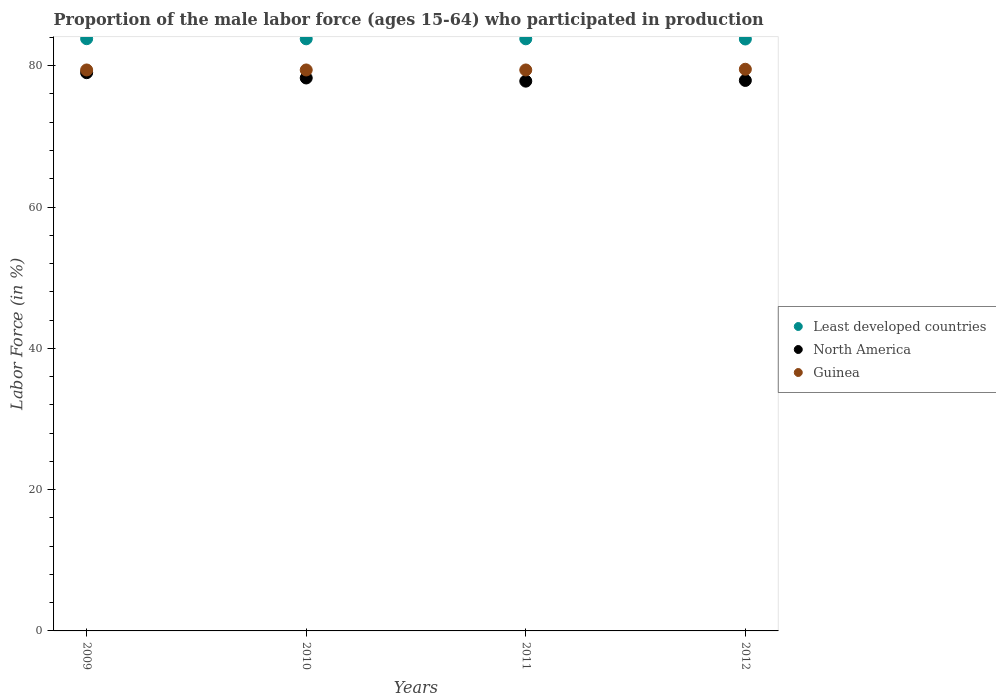What is the proportion of the male labor force who participated in production in North America in 2011?
Your answer should be compact. 77.82. Across all years, what is the maximum proportion of the male labor force who participated in production in Guinea?
Offer a terse response. 79.5. Across all years, what is the minimum proportion of the male labor force who participated in production in North America?
Offer a very short reply. 77.82. What is the total proportion of the male labor force who participated in production in Guinea in the graph?
Ensure brevity in your answer.  317.7. What is the difference between the proportion of the male labor force who participated in production in Least developed countries in 2010 and that in 2012?
Your response must be concise. 0.03. What is the difference between the proportion of the male labor force who participated in production in Least developed countries in 2011 and the proportion of the male labor force who participated in production in Guinea in 2009?
Offer a terse response. 4.41. What is the average proportion of the male labor force who participated in production in Least developed countries per year?
Your answer should be very brief. 83.81. In the year 2011, what is the difference between the proportion of the male labor force who participated in production in Guinea and proportion of the male labor force who participated in production in Least developed countries?
Your response must be concise. -4.41. What is the ratio of the proportion of the male labor force who participated in production in North America in 2009 to that in 2010?
Your response must be concise. 1.01. What is the difference between the highest and the second highest proportion of the male labor force who participated in production in Least developed countries?
Provide a short and direct response. 0.02. What is the difference between the highest and the lowest proportion of the male labor force who participated in production in North America?
Ensure brevity in your answer.  1.2. In how many years, is the proportion of the male labor force who participated in production in Least developed countries greater than the average proportion of the male labor force who participated in production in Least developed countries taken over all years?
Make the answer very short. 3. Does the proportion of the male labor force who participated in production in Least developed countries monotonically increase over the years?
Offer a terse response. No. Is the proportion of the male labor force who participated in production in Guinea strictly less than the proportion of the male labor force who participated in production in North America over the years?
Give a very brief answer. No. How many dotlines are there?
Offer a very short reply. 3. Does the graph contain any zero values?
Offer a very short reply. No. Where does the legend appear in the graph?
Offer a terse response. Center right. What is the title of the graph?
Your answer should be compact. Proportion of the male labor force (ages 15-64) who participated in production. What is the label or title of the Y-axis?
Offer a very short reply. Labor Force (in %). What is the Labor Force (in %) of Least developed countries in 2009?
Offer a terse response. 83.83. What is the Labor Force (in %) of North America in 2009?
Your answer should be very brief. 79.02. What is the Labor Force (in %) of Guinea in 2009?
Provide a short and direct response. 79.4. What is the Labor Force (in %) of Least developed countries in 2010?
Keep it short and to the point. 83.81. What is the Labor Force (in %) of North America in 2010?
Offer a terse response. 78.27. What is the Labor Force (in %) of Guinea in 2010?
Your answer should be very brief. 79.4. What is the Labor Force (in %) in Least developed countries in 2011?
Keep it short and to the point. 83.81. What is the Labor Force (in %) of North America in 2011?
Ensure brevity in your answer.  77.82. What is the Labor Force (in %) in Guinea in 2011?
Your response must be concise. 79.4. What is the Labor Force (in %) in Least developed countries in 2012?
Offer a very short reply. 83.78. What is the Labor Force (in %) of North America in 2012?
Keep it short and to the point. 77.92. What is the Labor Force (in %) in Guinea in 2012?
Offer a very short reply. 79.5. Across all years, what is the maximum Labor Force (in %) of Least developed countries?
Offer a very short reply. 83.83. Across all years, what is the maximum Labor Force (in %) of North America?
Give a very brief answer. 79.02. Across all years, what is the maximum Labor Force (in %) of Guinea?
Your answer should be very brief. 79.5. Across all years, what is the minimum Labor Force (in %) of Least developed countries?
Provide a short and direct response. 83.78. Across all years, what is the minimum Labor Force (in %) in North America?
Give a very brief answer. 77.82. Across all years, what is the minimum Labor Force (in %) of Guinea?
Keep it short and to the point. 79.4. What is the total Labor Force (in %) of Least developed countries in the graph?
Provide a succinct answer. 335.23. What is the total Labor Force (in %) in North America in the graph?
Offer a terse response. 313.02. What is the total Labor Force (in %) in Guinea in the graph?
Ensure brevity in your answer.  317.7. What is the difference between the Labor Force (in %) of Least developed countries in 2009 and that in 2010?
Provide a succinct answer. 0.02. What is the difference between the Labor Force (in %) in North America in 2009 and that in 2010?
Your answer should be compact. 0.75. What is the difference between the Labor Force (in %) in Guinea in 2009 and that in 2010?
Keep it short and to the point. 0. What is the difference between the Labor Force (in %) of Least developed countries in 2009 and that in 2011?
Make the answer very short. 0.02. What is the difference between the Labor Force (in %) of North America in 2009 and that in 2011?
Your response must be concise. 1.2. What is the difference between the Labor Force (in %) of Least developed countries in 2009 and that in 2012?
Ensure brevity in your answer.  0.04. What is the difference between the Labor Force (in %) in North America in 2009 and that in 2012?
Provide a short and direct response. 1.1. What is the difference between the Labor Force (in %) in Least developed countries in 2010 and that in 2011?
Your response must be concise. 0. What is the difference between the Labor Force (in %) in North America in 2010 and that in 2011?
Provide a short and direct response. 0.45. What is the difference between the Labor Force (in %) in Guinea in 2010 and that in 2011?
Your response must be concise. 0. What is the difference between the Labor Force (in %) in Least developed countries in 2010 and that in 2012?
Provide a short and direct response. 0.03. What is the difference between the Labor Force (in %) in North America in 2010 and that in 2012?
Your response must be concise. 0.35. What is the difference between the Labor Force (in %) of Guinea in 2010 and that in 2012?
Give a very brief answer. -0.1. What is the difference between the Labor Force (in %) of Least developed countries in 2011 and that in 2012?
Ensure brevity in your answer.  0.03. What is the difference between the Labor Force (in %) of North America in 2011 and that in 2012?
Give a very brief answer. -0.1. What is the difference between the Labor Force (in %) of Least developed countries in 2009 and the Labor Force (in %) of North America in 2010?
Provide a short and direct response. 5.56. What is the difference between the Labor Force (in %) in Least developed countries in 2009 and the Labor Force (in %) in Guinea in 2010?
Your response must be concise. 4.43. What is the difference between the Labor Force (in %) in North America in 2009 and the Labor Force (in %) in Guinea in 2010?
Your answer should be very brief. -0.38. What is the difference between the Labor Force (in %) of Least developed countries in 2009 and the Labor Force (in %) of North America in 2011?
Offer a very short reply. 6.01. What is the difference between the Labor Force (in %) in Least developed countries in 2009 and the Labor Force (in %) in Guinea in 2011?
Offer a terse response. 4.43. What is the difference between the Labor Force (in %) of North America in 2009 and the Labor Force (in %) of Guinea in 2011?
Offer a very short reply. -0.38. What is the difference between the Labor Force (in %) in Least developed countries in 2009 and the Labor Force (in %) in North America in 2012?
Offer a terse response. 5.91. What is the difference between the Labor Force (in %) in Least developed countries in 2009 and the Labor Force (in %) in Guinea in 2012?
Your response must be concise. 4.33. What is the difference between the Labor Force (in %) in North America in 2009 and the Labor Force (in %) in Guinea in 2012?
Give a very brief answer. -0.48. What is the difference between the Labor Force (in %) of Least developed countries in 2010 and the Labor Force (in %) of North America in 2011?
Your answer should be compact. 5.99. What is the difference between the Labor Force (in %) of Least developed countries in 2010 and the Labor Force (in %) of Guinea in 2011?
Offer a very short reply. 4.41. What is the difference between the Labor Force (in %) in North America in 2010 and the Labor Force (in %) in Guinea in 2011?
Offer a very short reply. -1.13. What is the difference between the Labor Force (in %) of Least developed countries in 2010 and the Labor Force (in %) of North America in 2012?
Your answer should be very brief. 5.89. What is the difference between the Labor Force (in %) of Least developed countries in 2010 and the Labor Force (in %) of Guinea in 2012?
Provide a short and direct response. 4.31. What is the difference between the Labor Force (in %) of North America in 2010 and the Labor Force (in %) of Guinea in 2012?
Offer a terse response. -1.23. What is the difference between the Labor Force (in %) in Least developed countries in 2011 and the Labor Force (in %) in North America in 2012?
Keep it short and to the point. 5.89. What is the difference between the Labor Force (in %) of Least developed countries in 2011 and the Labor Force (in %) of Guinea in 2012?
Ensure brevity in your answer.  4.31. What is the difference between the Labor Force (in %) of North America in 2011 and the Labor Force (in %) of Guinea in 2012?
Provide a short and direct response. -1.68. What is the average Labor Force (in %) of Least developed countries per year?
Provide a succinct answer. 83.81. What is the average Labor Force (in %) of North America per year?
Provide a succinct answer. 78.25. What is the average Labor Force (in %) in Guinea per year?
Give a very brief answer. 79.42. In the year 2009, what is the difference between the Labor Force (in %) in Least developed countries and Labor Force (in %) in North America?
Provide a short and direct response. 4.81. In the year 2009, what is the difference between the Labor Force (in %) of Least developed countries and Labor Force (in %) of Guinea?
Provide a succinct answer. 4.43. In the year 2009, what is the difference between the Labor Force (in %) of North America and Labor Force (in %) of Guinea?
Offer a terse response. -0.38. In the year 2010, what is the difference between the Labor Force (in %) in Least developed countries and Labor Force (in %) in North America?
Provide a short and direct response. 5.54. In the year 2010, what is the difference between the Labor Force (in %) of Least developed countries and Labor Force (in %) of Guinea?
Your answer should be very brief. 4.41. In the year 2010, what is the difference between the Labor Force (in %) in North America and Labor Force (in %) in Guinea?
Keep it short and to the point. -1.13. In the year 2011, what is the difference between the Labor Force (in %) in Least developed countries and Labor Force (in %) in North America?
Keep it short and to the point. 5.99. In the year 2011, what is the difference between the Labor Force (in %) in Least developed countries and Labor Force (in %) in Guinea?
Ensure brevity in your answer.  4.41. In the year 2011, what is the difference between the Labor Force (in %) of North America and Labor Force (in %) of Guinea?
Ensure brevity in your answer.  -1.58. In the year 2012, what is the difference between the Labor Force (in %) in Least developed countries and Labor Force (in %) in North America?
Give a very brief answer. 5.87. In the year 2012, what is the difference between the Labor Force (in %) in Least developed countries and Labor Force (in %) in Guinea?
Ensure brevity in your answer.  4.28. In the year 2012, what is the difference between the Labor Force (in %) in North America and Labor Force (in %) in Guinea?
Your response must be concise. -1.58. What is the ratio of the Labor Force (in %) in Least developed countries in 2009 to that in 2010?
Provide a short and direct response. 1. What is the ratio of the Labor Force (in %) of North America in 2009 to that in 2010?
Make the answer very short. 1.01. What is the ratio of the Labor Force (in %) of Least developed countries in 2009 to that in 2011?
Ensure brevity in your answer.  1. What is the ratio of the Labor Force (in %) of North America in 2009 to that in 2011?
Your answer should be very brief. 1.02. What is the ratio of the Labor Force (in %) in Guinea in 2009 to that in 2011?
Keep it short and to the point. 1. What is the ratio of the Labor Force (in %) of North America in 2009 to that in 2012?
Your answer should be very brief. 1.01. What is the ratio of the Labor Force (in %) of Guinea in 2009 to that in 2012?
Offer a terse response. 1. What is the ratio of the Labor Force (in %) in Least developed countries in 2010 to that in 2011?
Keep it short and to the point. 1. What is the ratio of the Labor Force (in %) in North America in 2010 to that in 2011?
Your response must be concise. 1.01. What is the ratio of the Labor Force (in %) of Guinea in 2010 to that in 2011?
Ensure brevity in your answer.  1. What is the ratio of the Labor Force (in %) in North America in 2010 to that in 2012?
Your answer should be very brief. 1. What is the ratio of the Labor Force (in %) of North America in 2011 to that in 2012?
Provide a succinct answer. 1. What is the ratio of the Labor Force (in %) of Guinea in 2011 to that in 2012?
Make the answer very short. 1. What is the difference between the highest and the second highest Labor Force (in %) in Least developed countries?
Your response must be concise. 0.02. What is the difference between the highest and the second highest Labor Force (in %) in North America?
Offer a terse response. 0.75. What is the difference between the highest and the lowest Labor Force (in %) in Least developed countries?
Ensure brevity in your answer.  0.04. What is the difference between the highest and the lowest Labor Force (in %) of North America?
Your answer should be compact. 1.2. What is the difference between the highest and the lowest Labor Force (in %) of Guinea?
Make the answer very short. 0.1. 